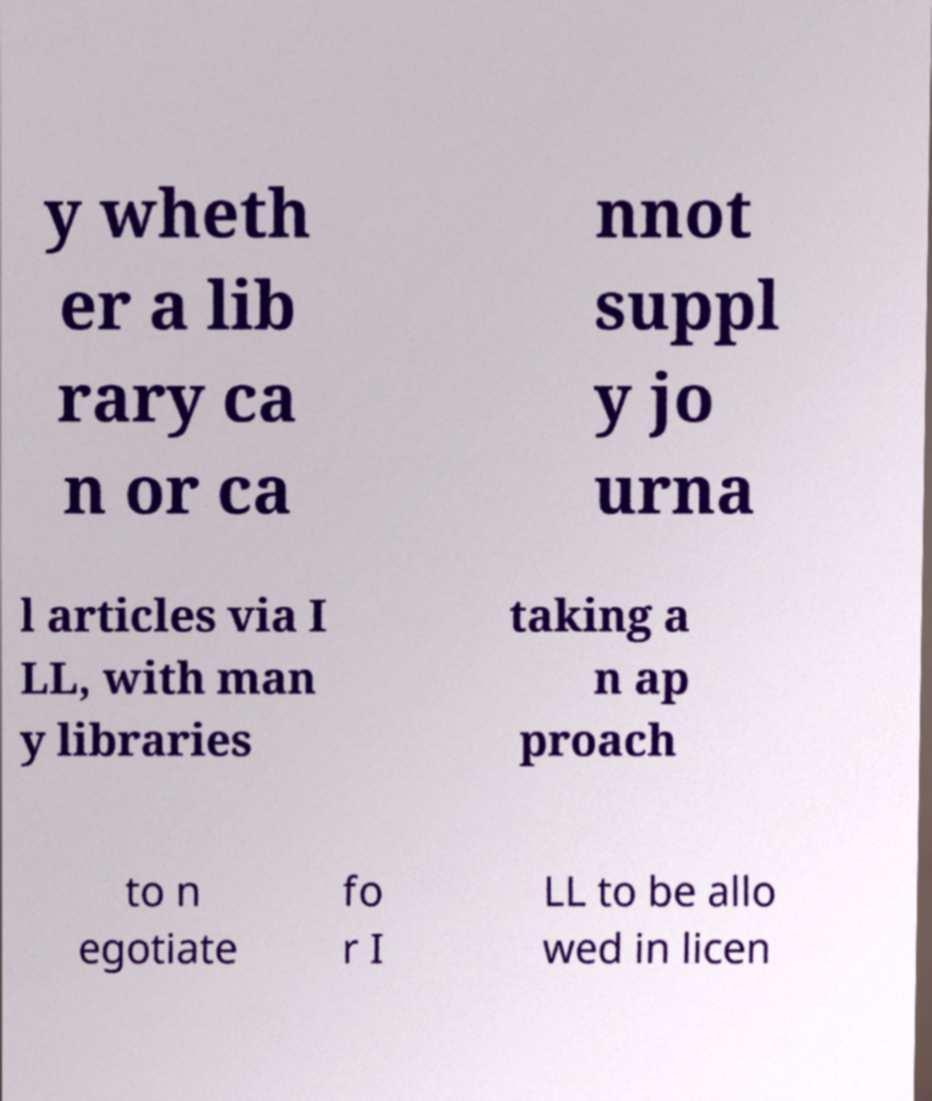I need the written content from this picture converted into text. Can you do that? y wheth er a lib rary ca n or ca nnot suppl y jo urna l articles via I LL, with man y libraries taking a n ap proach to n egotiate fo r I LL to be allo wed in licen 